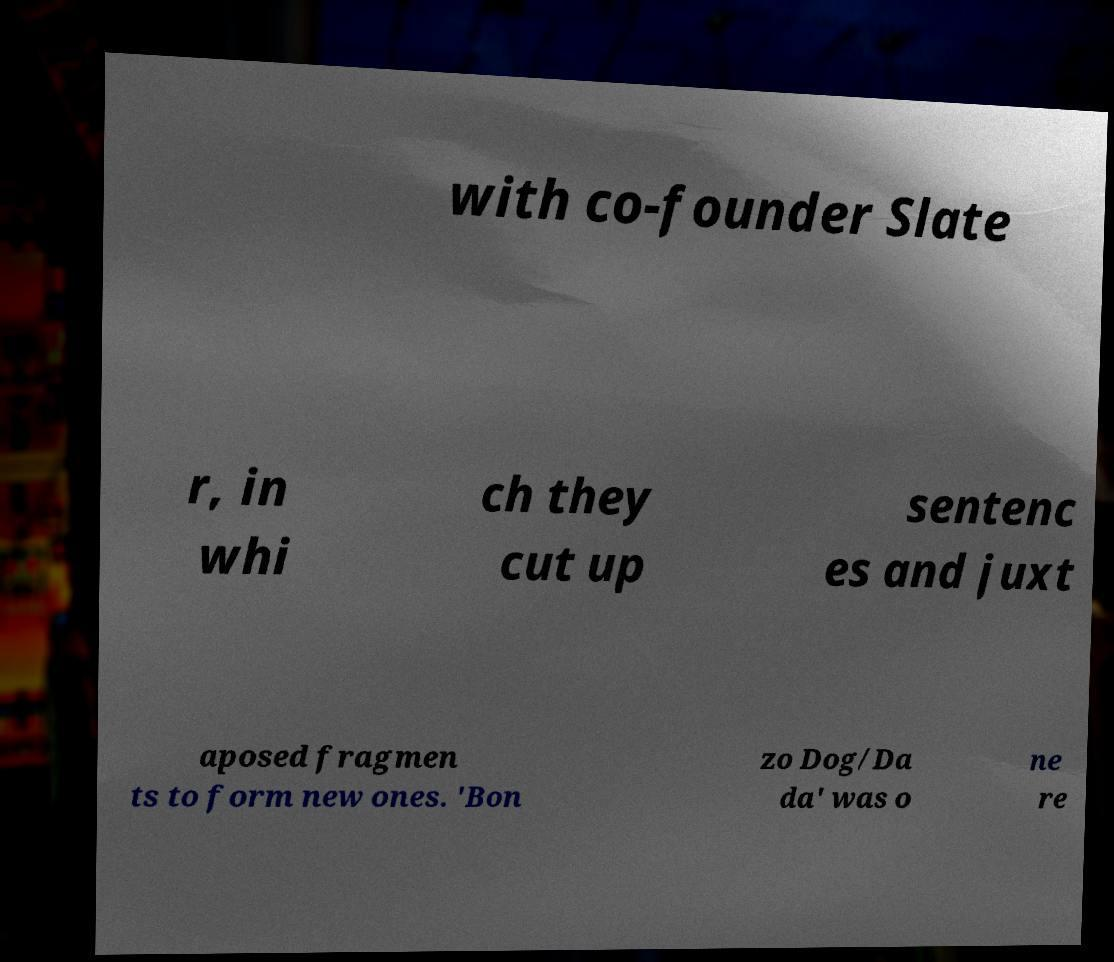Can you accurately transcribe the text from the provided image for me? with co-founder Slate r, in whi ch they cut up sentenc es and juxt aposed fragmen ts to form new ones. 'Bon zo Dog/Da da' was o ne re 